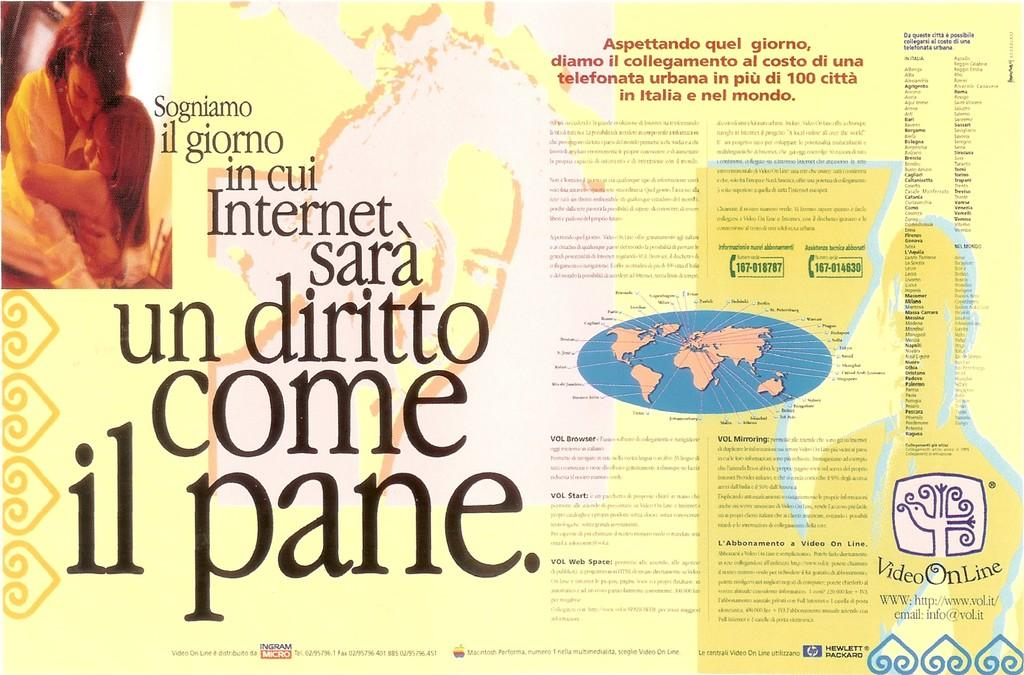What type of visual is the image? The image is a poster. Who or what is depicted on the poster? There are two people depicted on the poster. What additional element can be seen on the poster? There is a map on the poster. Are there any words or letters on the poster? Yes, there is text on the poster. What type of scarf is the person on the left wearing in the image? There is no scarf visible on the person on the left in the image. How does the hearing of the people on the poster change throughout the day? The poster does not depict any information about the hearing of the people, so we cannot determine how it changes throughout the day. 